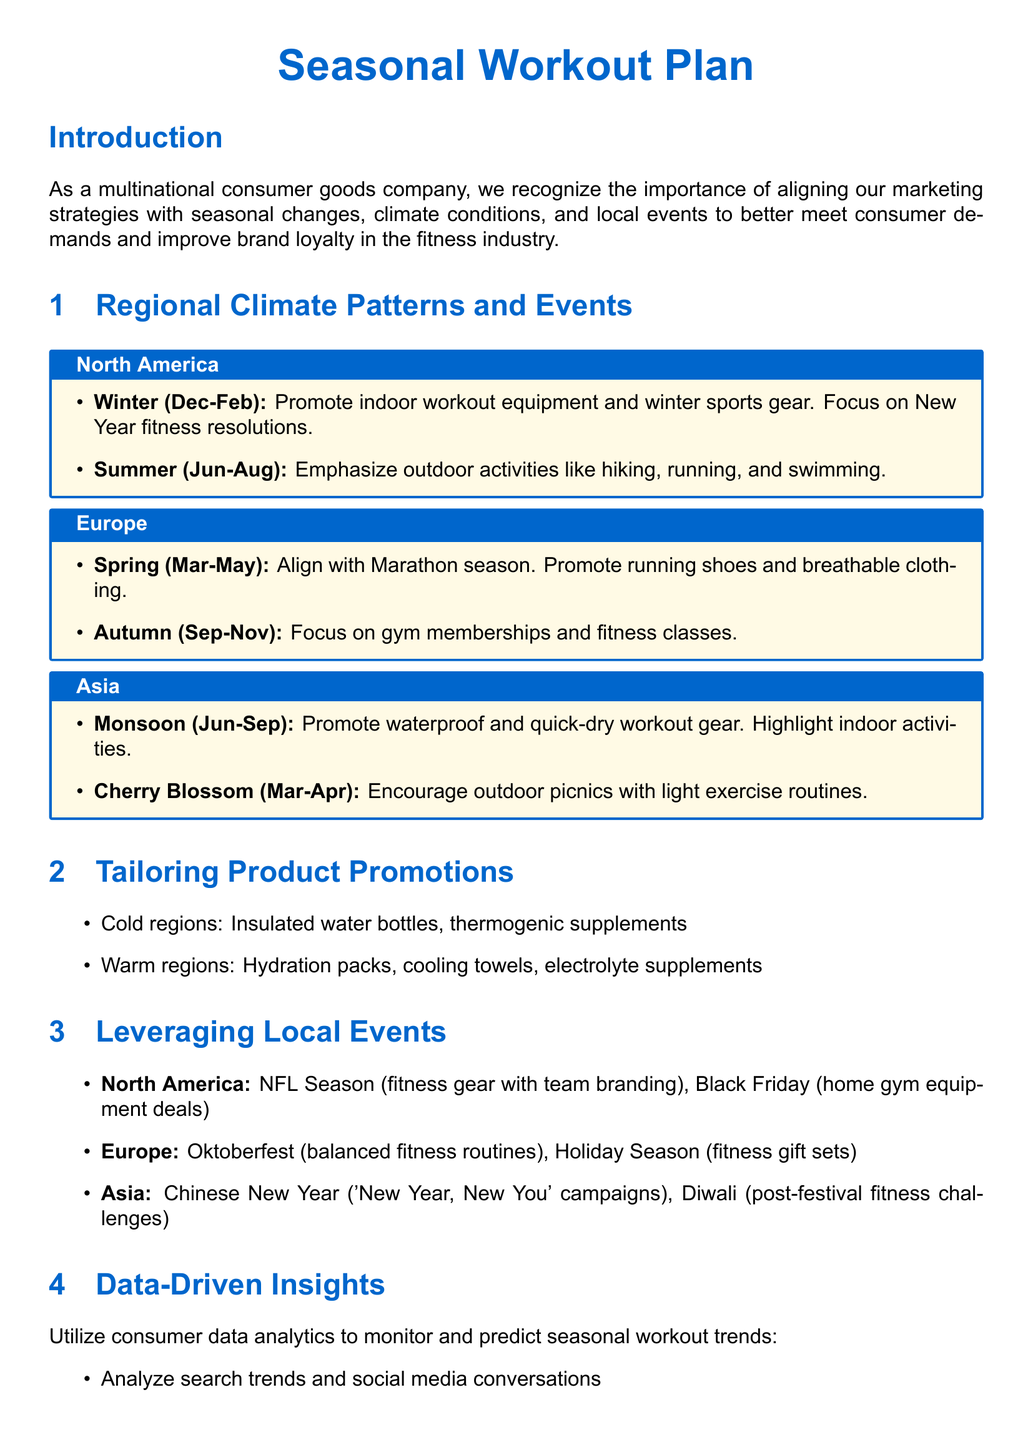What are the two main workout seasons in North America? The two main workout seasons in North America according to the document are Winter and Summer.
Answer: Winter and Summer What type of workout gear is promoted during the Asian Monsoon season? The document suggests promoting waterproof and quick-dry workout gear during the Monsoon season in Asia.
Answer: Waterproof and quick-dry workout gear Which local event is highlighted for Tailoring Product Promotions in Europe? In Europe, the local event highlighted is Oktoberfest.
Answer: Oktoberfest What is the focus of fitness marketing in Autumn for Europe? The focus of fitness marketing in Autumn for Europe is on gym memberships and fitness classes.
Answer: Gym memberships and fitness classes What type of product is suggested for cold regions? The document lists insulated water bottles as a suggested product for cold regions.
Answer: Insulated water bottles Which seasonal activity does the document associate with Cherry Blossom in Asia? The document associates outdoor picnics with light exercise routines during the Cherry Blossom season in Asia.
Answer: Outdoor picnics with light exercise routines How does the document recommend leveraging local events in North America? It suggests promoting fitness gear with team branding during the NFL Season in North America.
Answer: Fitness gear with team branding What kind of consumer data should be analyzed according to the document? The document suggests analyzing search trends and social media conversations as part of consumer data analytics.
Answer: Search trends and social media conversations 